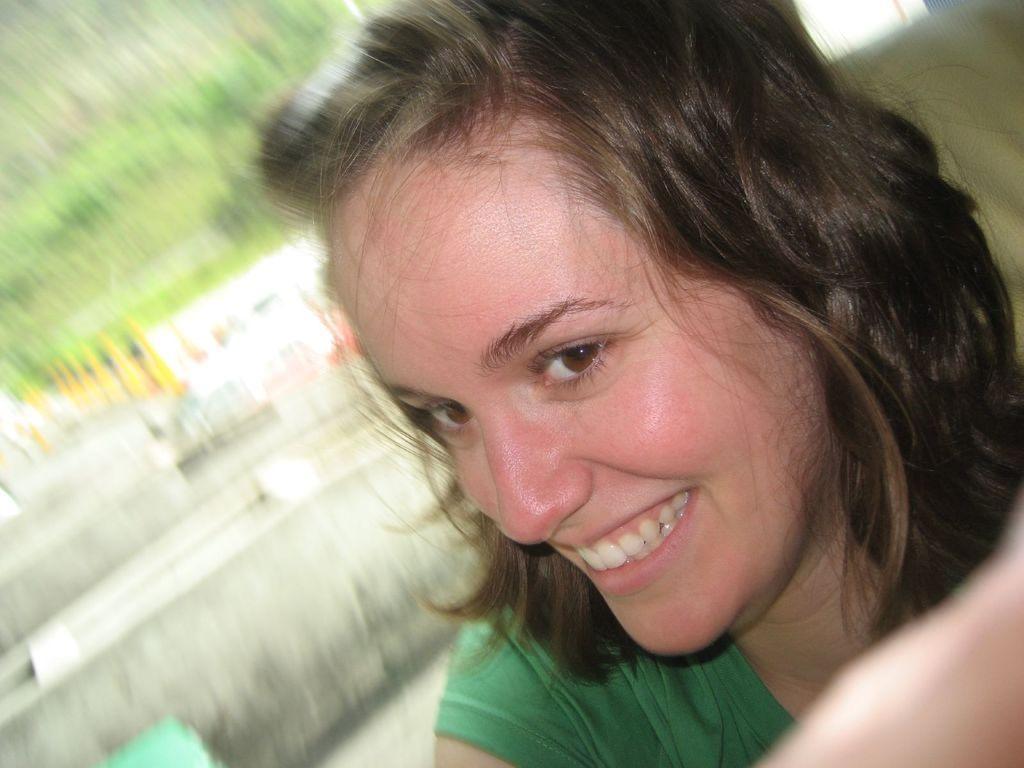In one or two sentences, can you explain what this image depicts? In this image we can see a person with smiling face and blur background. 